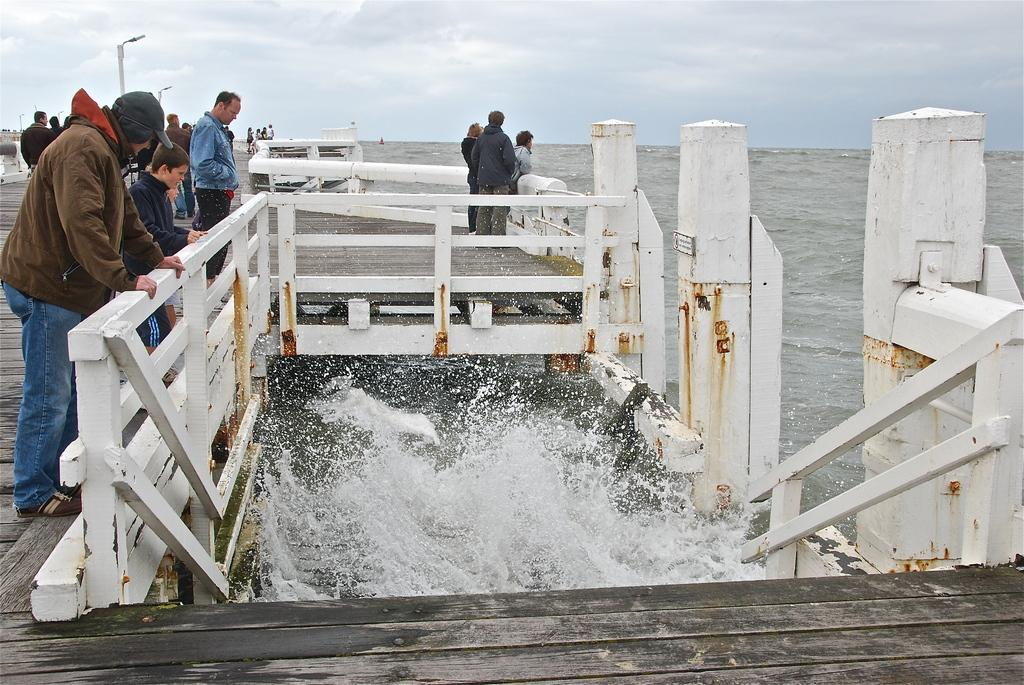What are the men in the image doing? The men are standing on a wooden structure on the left side of the image. What can be seen in the distance from their position? The men are looking at the sea. What is visible at the top of the image? The sky is visible at the top of the image. What type of knot can be seen in the image? There is no knot present in the image. Is there a fire visible in the image? No, there is no fire visible in the image. 